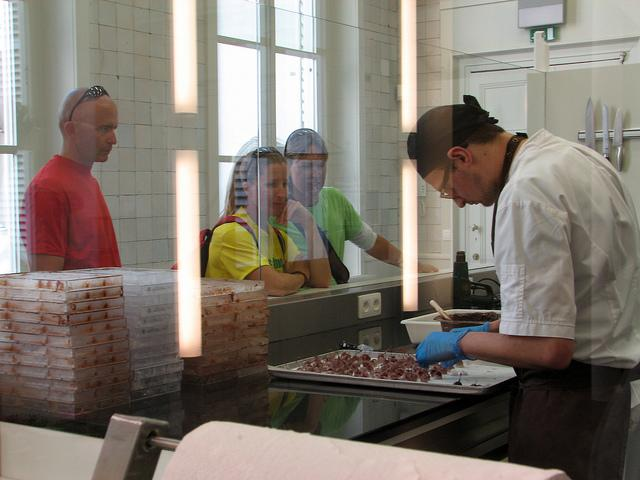What is the man using to cook?

Choices:
A) veggies
B) chocolate
C) meat
D) fruit chocolate 